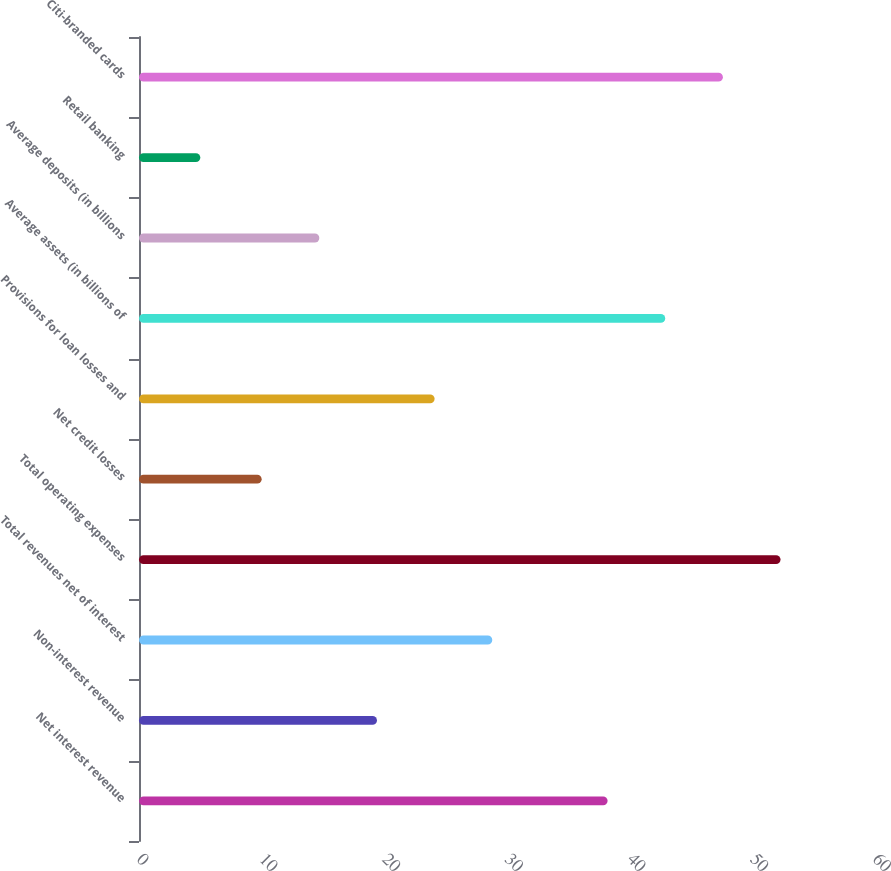Convert chart. <chart><loc_0><loc_0><loc_500><loc_500><bar_chart><fcel>Net interest revenue<fcel>Non-interest revenue<fcel>Total revenues net of interest<fcel>Total operating expenses<fcel>Net credit losses<fcel>Provisions for loan losses and<fcel>Average assets (in billions of<fcel>Average deposits (in billions<fcel>Retail banking<fcel>Citi-branded cards<nl><fcel>38.2<fcel>19.4<fcel>28.8<fcel>52.3<fcel>10<fcel>24.1<fcel>42.9<fcel>14.7<fcel>5<fcel>47.6<nl></chart> 